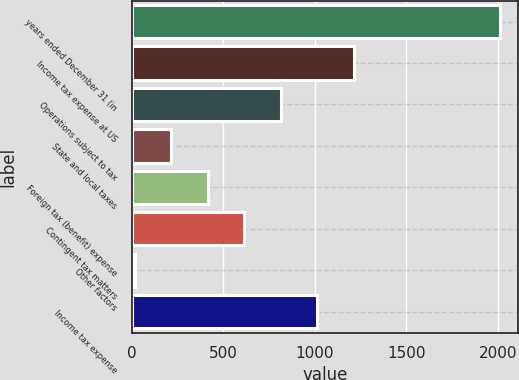<chart> <loc_0><loc_0><loc_500><loc_500><bar_chart><fcel>years ended December 31 (in<fcel>Income tax expense at US<fcel>Operations subject to tax<fcel>State and local taxes<fcel>Foreign tax (benefit) expense<fcel>Contingent tax matters<fcel>Other factors<fcel>Income tax expense<nl><fcel>2011<fcel>1213<fcel>814<fcel>215.5<fcel>415<fcel>614.5<fcel>16<fcel>1013.5<nl></chart> 